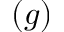Convert formula to latex. <formula><loc_0><loc_0><loc_500><loc_500>( g )</formula> 